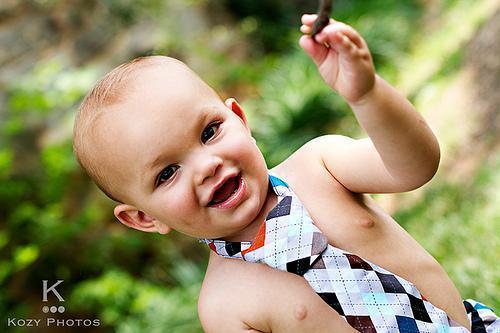How many children are in the picture?
Give a very brief answer. 1. 